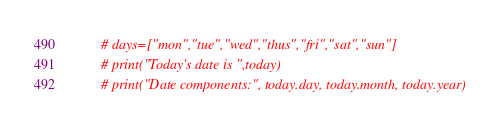<code> <loc_0><loc_0><loc_500><loc_500><_Python_>        # days=["mon","tue","wed","thus","fri","sat","sun"]
        # print("Today's date is ",today)
        # print("Date components:", today.day, today.month, today.year)</code> 